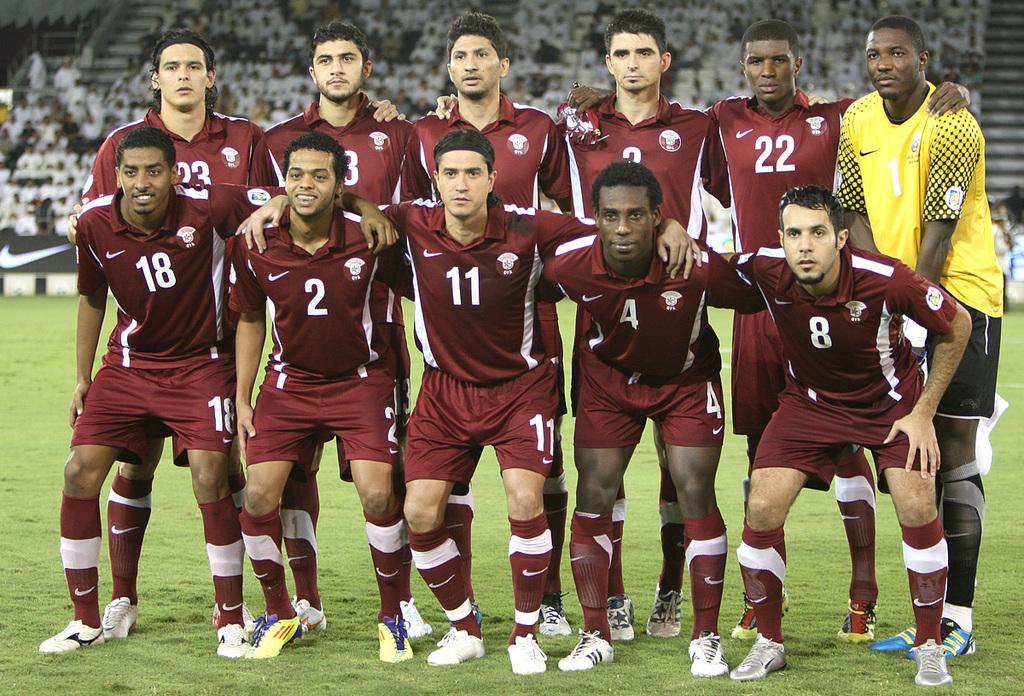<image>
Provide a brief description of the given image. Soccer players huddle up include number 11 front and center. 